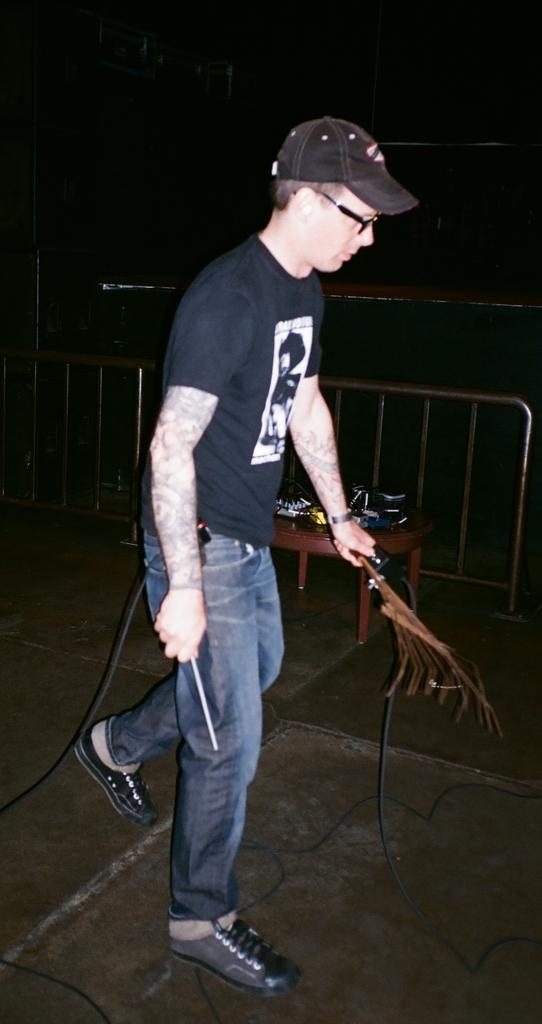What is the person in the image doing? The person is standing in the image. What is the person holding in the image? The person is holding an object. What can be seen in the background of the image? There is a table and a metal fence in the image. What is on the table in the image? There are objects on the table. What type of apparel is the person wearing in the image? The provided facts do not mention any apparel worn by the person in the image. How many snakes can be seen slithering around the metal fence in the image? There are no snakes present in the image. 